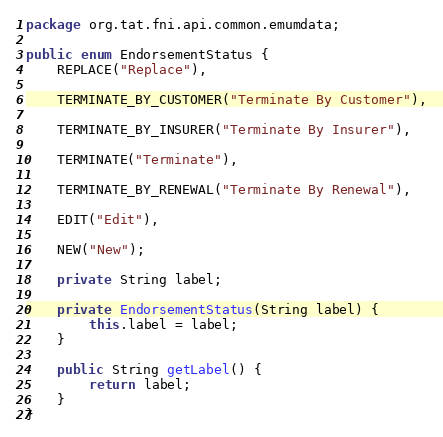Convert code to text. <code><loc_0><loc_0><loc_500><loc_500><_Java_>package org.tat.fni.api.common.emumdata;

public enum EndorsementStatus {
	REPLACE("Replace"),

	TERMINATE_BY_CUSTOMER("Terminate By Customer"),

	TERMINATE_BY_INSURER("Terminate By Insurer"),

	TERMINATE("Terminate"),

	TERMINATE_BY_RENEWAL("Terminate By Renewal"),

	EDIT("Edit"),

	NEW("New");

	private String label;

	private EndorsementStatus(String label) {
		this.label = label;
	}

	public String getLabel() {
		return label;
	}
}
</code> 